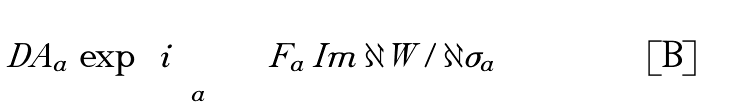Convert formula to latex. <formula><loc_0><loc_0><loc_500><loc_500>\int D A _ { a } \, \exp \left ( i \sum _ { a } \int F _ { a } \, { I m } \, \partial \tilde { W } / \partial \sigma _ { a } \right )</formula> 